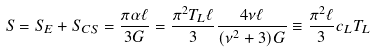<formula> <loc_0><loc_0><loc_500><loc_500>S = S _ { E } + S _ { C S } = \frac { \pi \alpha \ell } { 3 G } = \frac { \pi ^ { 2 } T _ { L } \ell } { 3 } \frac { 4 \nu \ell } { ( \nu ^ { 2 } + 3 ) G } \equiv \frac { \pi ^ { 2 } \ell } { 3 } c _ { L } T _ { L }</formula> 